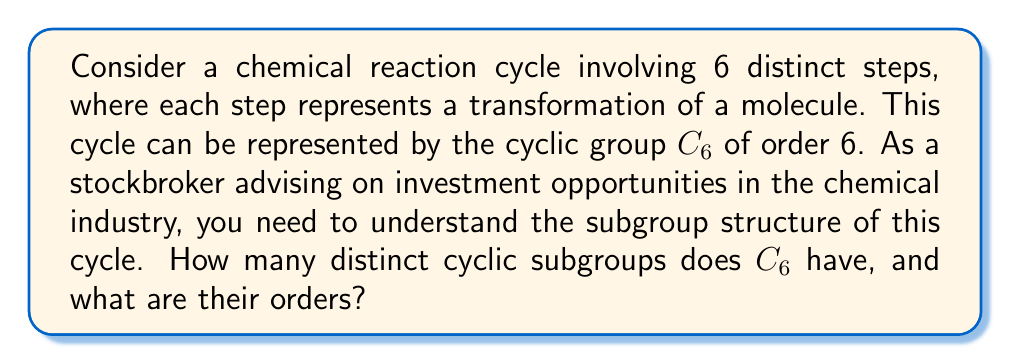Provide a solution to this math problem. To solve this problem, let's approach it step-by-step:

1) First, recall that the cyclic group $C_6$ is isomorphic to the additive group $\mathbb{Z}_6$ (integers modulo 6).

2) The subgroups of a cyclic group are always cyclic. To find the cyclic subgroups of $C_6$, we need to consider the generators of these subgroups.

3) The possible generators are the elements of $C_6$ that, when repeatedly applied, generate a subgroup. These are related to the divisors of the order of the group.

4) The divisors of 6 are 1, 2, 3, and 6.

5) Let's consider each divisor:
   
   - 1: This corresponds to the trivial subgroup $\{e\}$ (identity element only).
   - 2: This generates a subgroup of order 3: $\{e, r^2, r^4\}$ where $r$ is a generator of $C_6$.
   - 3: This generates a subgroup of order 2: $\{e, r^3\}$.
   - 6: This generates the entire group $C_6$.

6) Therefore, $C_6$ has 4 distinct cyclic subgroups.

7) The orders of these subgroups are 1, 2, 3, and 6, corresponding to the divisors of 6.

From an investment perspective, understanding these subgroups could provide insight into potential partial reaction cycles or intermediate stages in the chemical process, which might represent opportunities for optimization or new product development.
Answer: $C_6$ has 4 distinct cyclic subgroups with orders 1, 2, 3, and 6. 